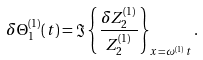<formula> <loc_0><loc_0><loc_500><loc_500>\delta \Theta _ { 1 } ^ { ( 1 ) } ( t ) = \Im \left \{ \frac { \delta Z _ { 2 } ^ { ( 1 ) } } { Z _ { 2 } ^ { ( 1 ) } } \right \} _ { x = \omega ^ { ( 1 ) } \, t } .</formula> 